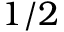Convert formula to latex. <formula><loc_0><loc_0><loc_500><loc_500>1 / 2</formula> 